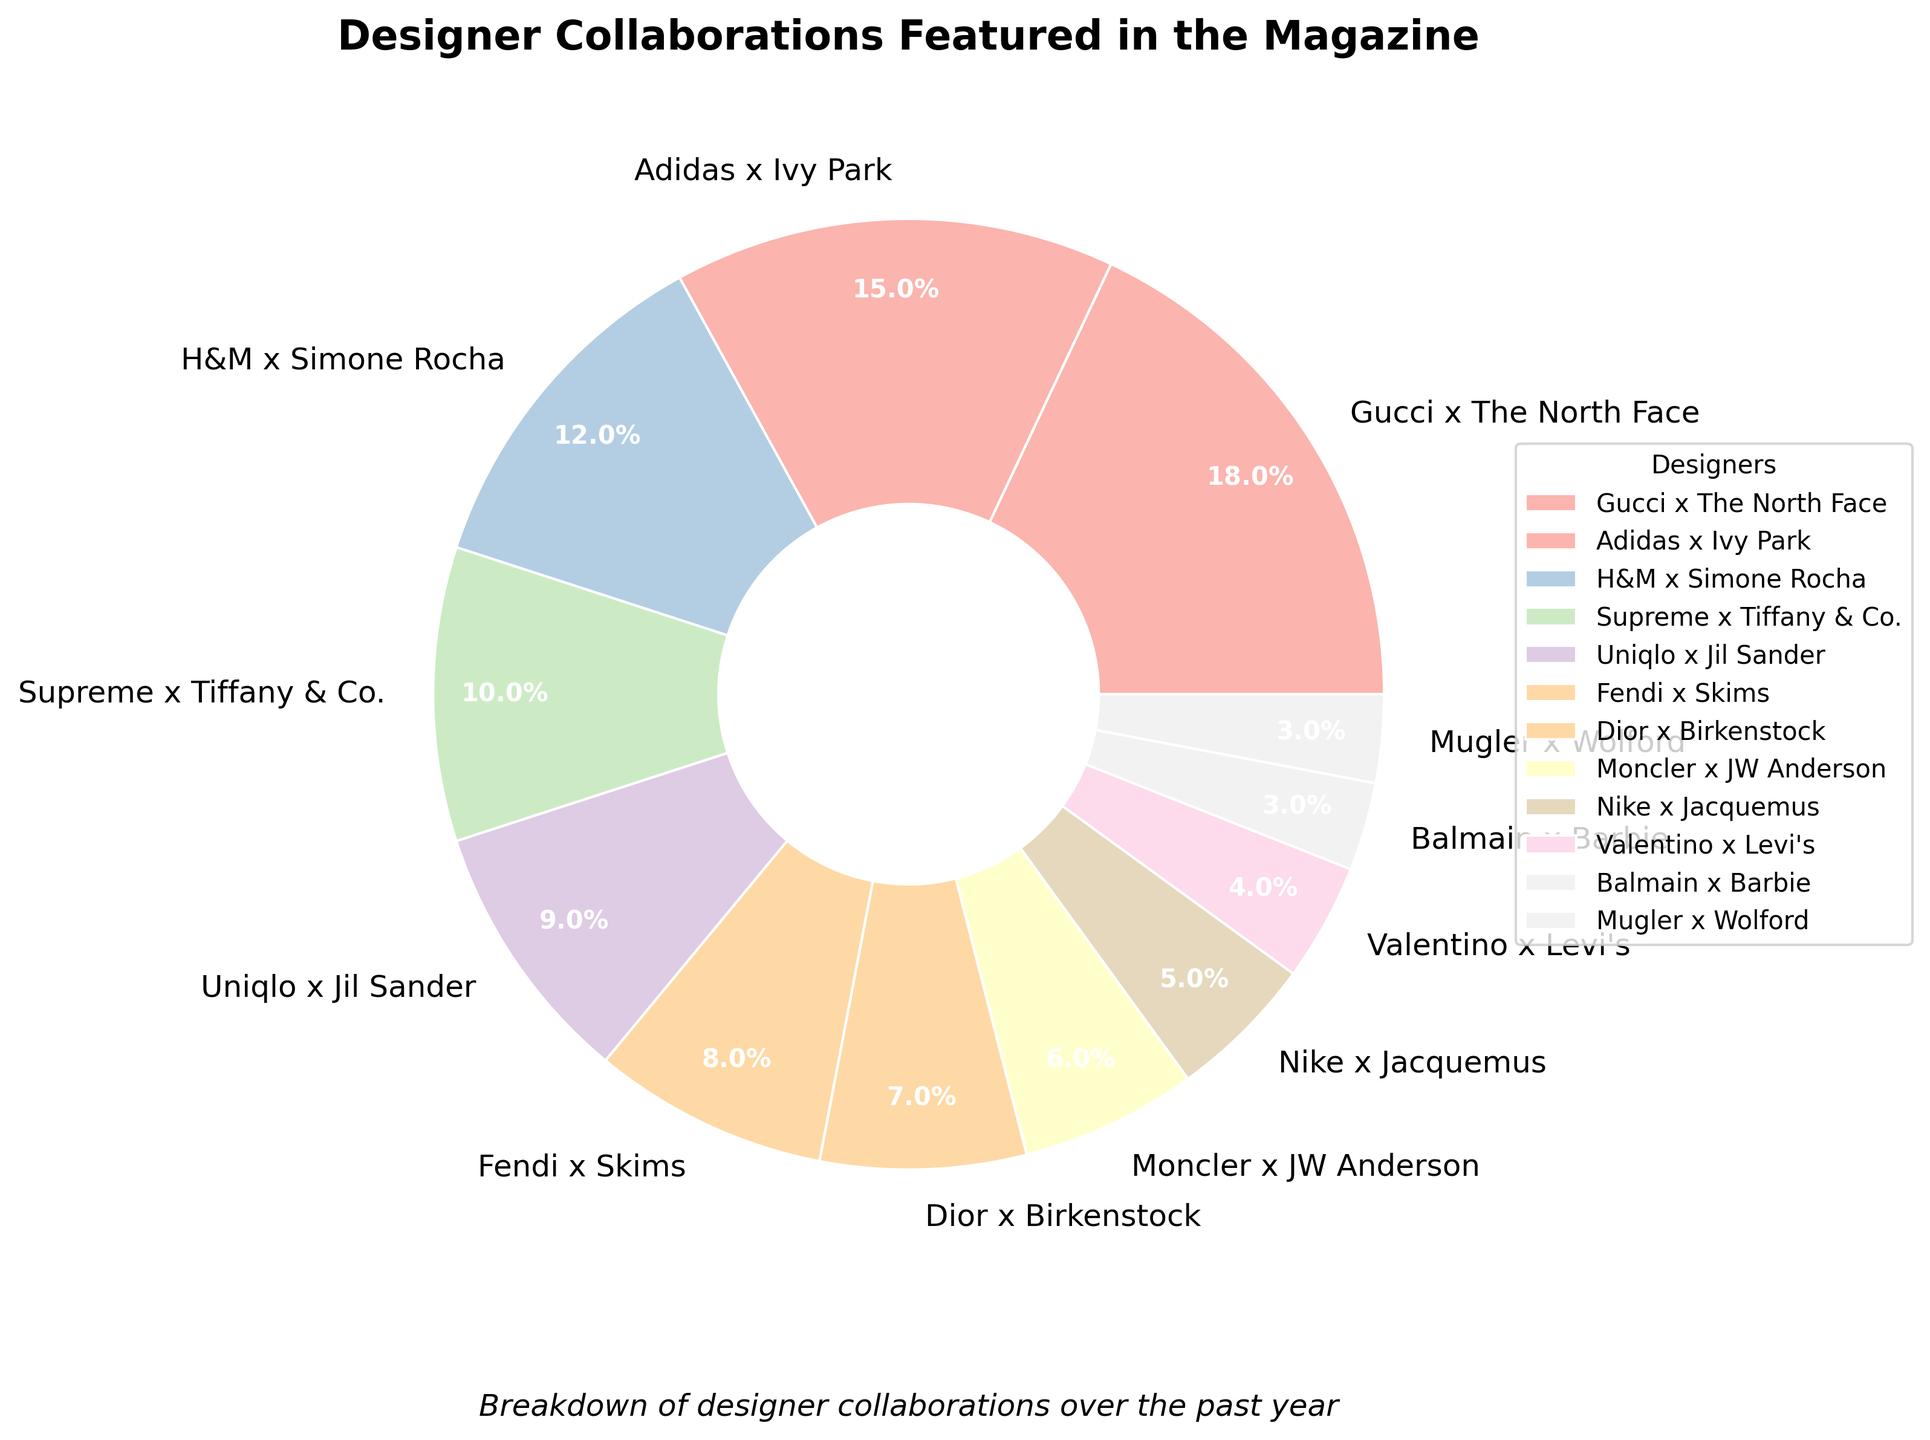What's the largest designer collaboration featured in the magazine? To find the largest collaboration, look for the section with the largest percentage. The largest percentage is 18%.
Answer: Gucci x The North Face Which designer collaboration has a 15% feature rate? Locate the segment with the 15% label, which corresponds to the collaboration listed as 15%.
Answer: Adidas x Ivy Park How many designer collaborations have an equal feature rate of 3% each? Count the segments with the label 3%. There are two segments with this percentage.
Answer: 2 (Balmain x Barbie and Mugler x Wolford) What is the combined percentage of the top three designer collaborations? Add the percentages of the top three collaborations: 18% + 15% + 12% = 45%.
Answer: 45% Which designer collaboration has a lower feature rate: Supreme x Tiffany & Co. or Dior x Birkenstock? Compare the percentages for Supreme x Tiffany & Co. (10%) and Dior x Birkenstock (7%).
Answer: Dior x Birkenstock What's the difference in feature percentage between Uniqlo x Jil Sander and Nike x Jacquemus? Subtract the lower percentage from the higher percentage: 9% - 5% = 4%.
Answer: 4% What proportion of all designer collaborations have a feature rate greater than or equal to 10%? Identify the segments with percentages 10% or higher (4 segments: 18%, 15%, 12%, and 10%). There are 4 out of 12 total segments. \( \frac{4}{12} = \frac{1}{3} \text{ or } 33.33% \)
Answer: 33.33% What is the total percentage of features for collaborations not breaking the 5% threshold? Add the percentages for the segments less than or equal to 5% (Nike x Jacquemus 5%, Valentino x Levi's 4%, Balmain x Barbie 3%, Mugler x Wolford 3%). 5% + 4% + 3% + 3% = 15%.
Answer: 15% Which collaboration segment appears in the colors most similar to pastel shades? The colors of the pie chart correspond to the collaborations, which use pastel shades. Hence, visually, all segments share similar pastel coloring.
Answer: All collaborations 